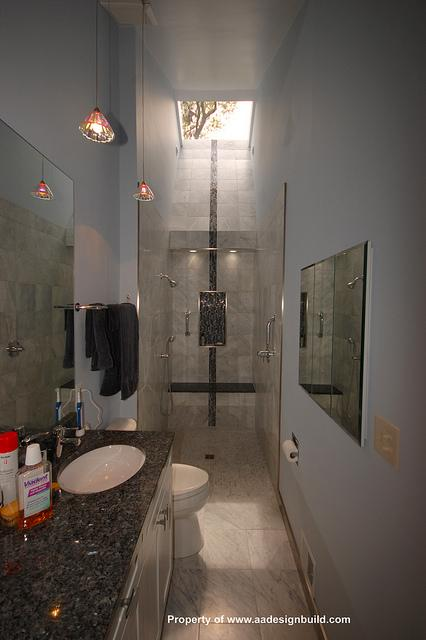What color is the fluid in the small container with the white cap on the top? Please explain your reasoning. red. The color is red. 